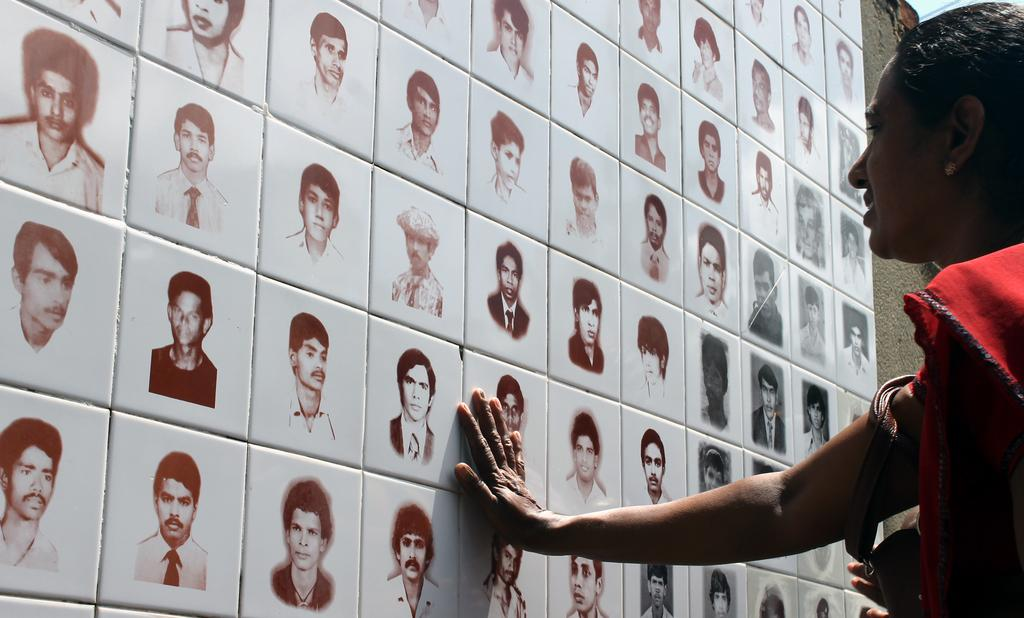What is present on the wall in the image? The wall has tiles on it. What is depicted on the tiles? There are pictures of people on the tiles. Can you describe the interaction between the person and the wall in the image? A person is touching the wall in the image. What direction is the stranger running in the image? There is no stranger or running depicted in the image. 